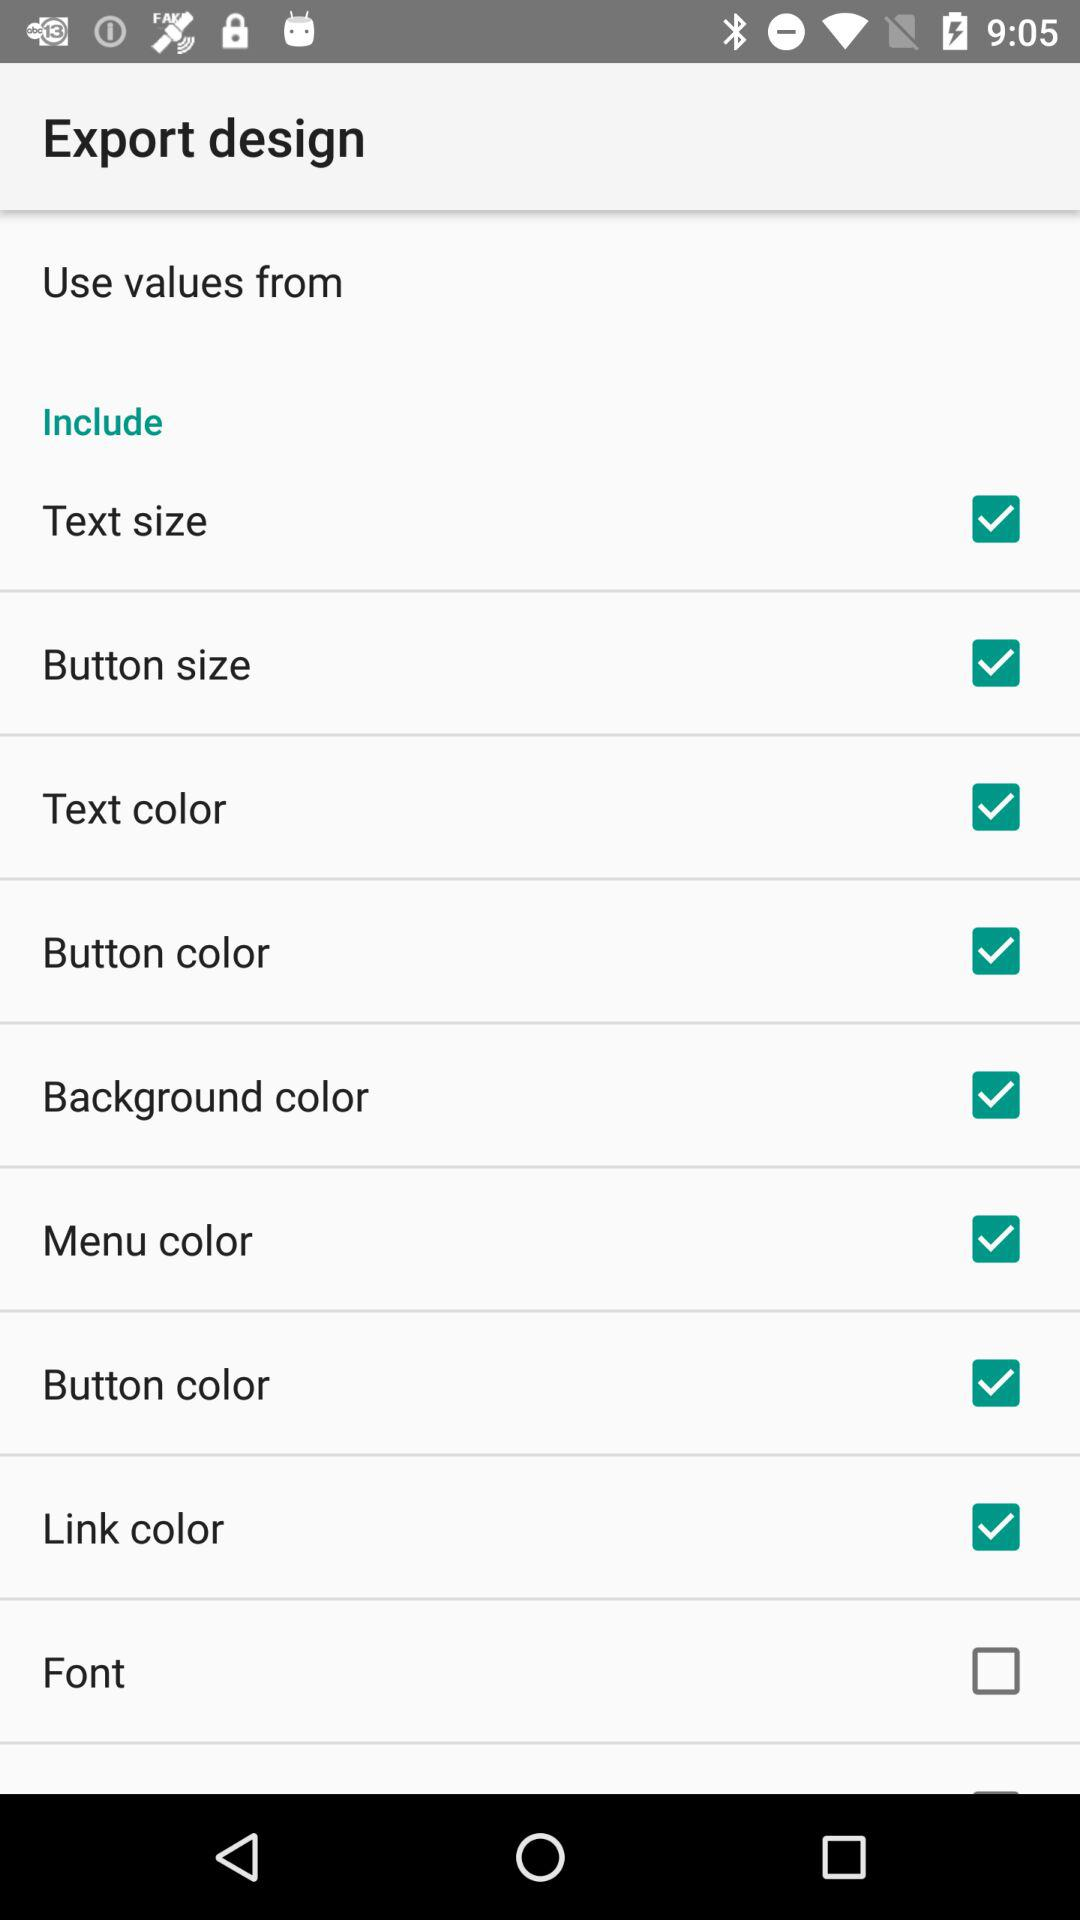What is the status of the "Text color"? The status is "on". 